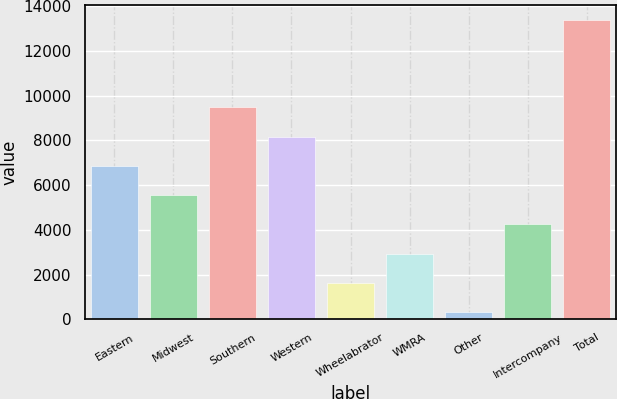Convert chart. <chart><loc_0><loc_0><loc_500><loc_500><bar_chart><fcel>Eastern<fcel>Midwest<fcel>Southern<fcel>Western<fcel>Wheelabrator<fcel>WMRA<fcel>Other<fcel>Intercompany<fcel>Total<nl><fcel>6859<fcel>5553.2<fcel>9470.6<fcel>8164.8<fcel>1635.8<fcel>2941.6<fcel>330<fcel>4247.4<fcel>13388<nl></chart> 